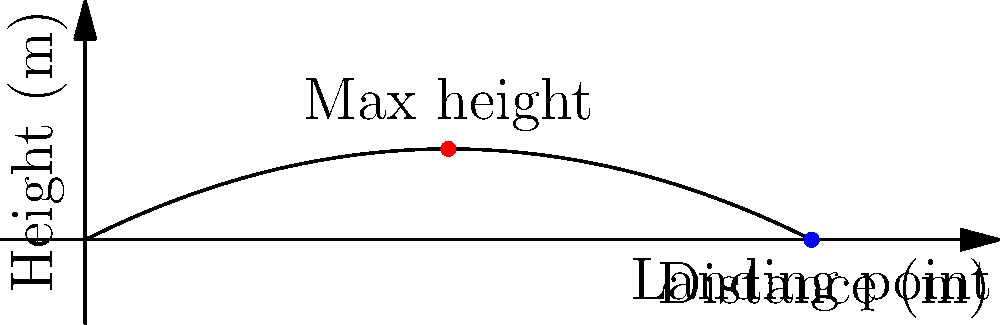In a thrilling scene from an Adam Beach movie, his character throws a tomahawk. The trajectory of the tomahawk can be modeled by the function $h(x) = -0.05x^2 + 0.5x$, where $h$ is the height in meters and $x$ is the horizontal distance in meters. Find the maximum height reached by the tomahawk and the horizontal distance it travels before hitting the ground. To solve this problem, we'll follow these steps:

1. Find the maximum height:
   a) The maximum height occurs at the vertex of the parabola.
   b) For a quadratic function $f(x) = ax^2 + bx + c$, the x-coordinate of the vertex is given by $x = -\frac{b}{2a}$.
   c) In our case, $a = -0.05$ and $b = 0.5$.
   d) $x = -\frac{0.5}{2(-0.05)} = 5$ meters
   e) The maximum height is $h(5) = -0.05(5)^2 + 0.5(5) = 1.25$ meters

2. Find the horizontal distance traveled:
   a) The tomahawk hits the ground when $h(x) = 0$.
   b) Solve the equation: $-0.05x^2 + 0.5x = 0$
   c) Factor out $x$: $x(-0.05x + 0.5) = 0$
   d) Solve: $x = 0$ or $x = 10$
   e) Since $x = 0$ is the starting point, the landing point is at $x = 10$ meters

Therefore, the tomahawk reaches a maximum height of 1.25 meters and travels a horizontal distance of 10 meters before hitting the ground.
Answer: Maximum height: 1.25 m; Horizontal distance: 10 m 